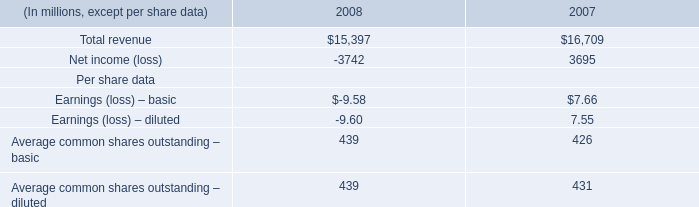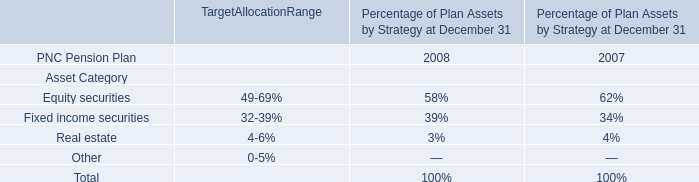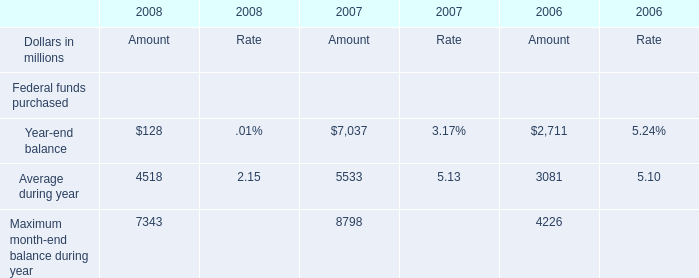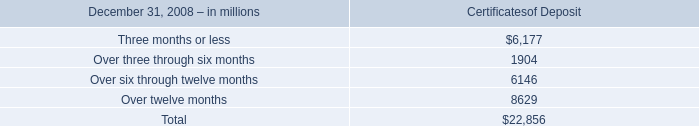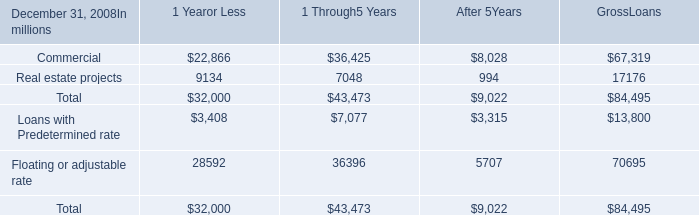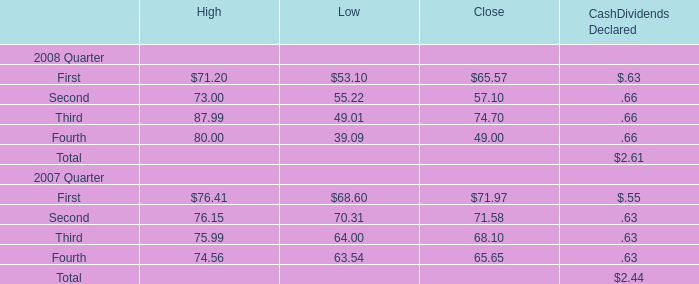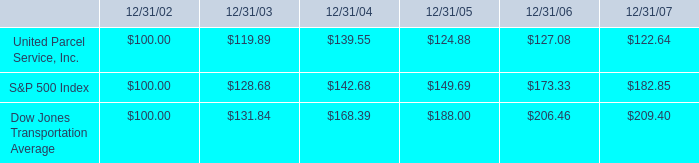what was the percentage five year cumulative total return for united parcel service inc . for the period ended 12/31/07? 
Computations: ((122.64 - 100) / 100)
Answer: 0.2264. 